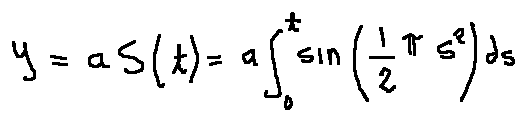<formula> <loc_0><loc_0><loc_500><loc_500>y = a S ( t ) = a \int \lim i t s _ { 0 } ^ { t } \sin ( \frac { 1 } { 2 } \pi s ^ { 2 } ) d s</formula> 